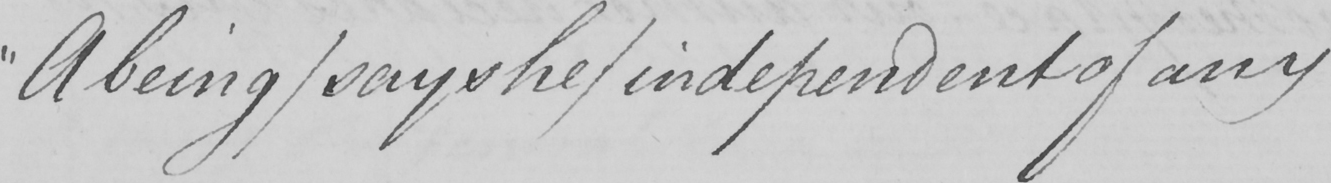Please transcribe the handwritten text in this image. " A being/says he/independent of any 